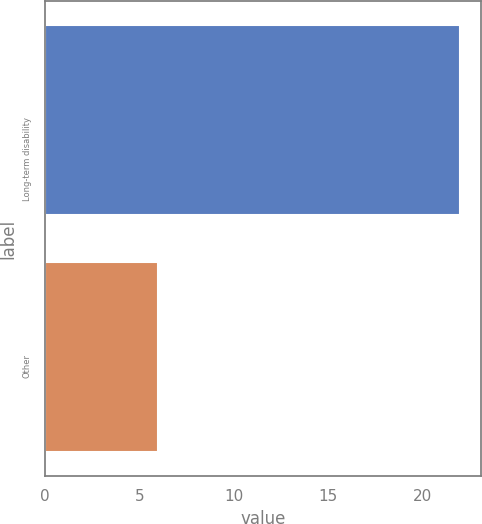Convert chart to OTSL. <chart><loc_0><loc_0><loc_500><loc_500><bar_chart><fcel>Long-term disability<fcel>Other<nl><fcel>22<fcel>6<nl></chart> 